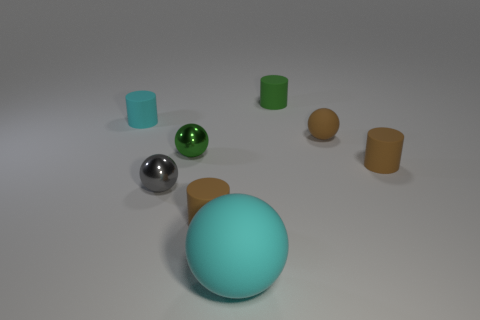Subtract all brown cylinders. How many were subtracted if there are1brown cylinders left? 1 Add 1 large cyan matte objects. How many objects exist? 9 Subtract all red balls. Subtract all brown cylinders. How many balls are left? 4 Add 5 small brown objects. How many small brown objects are left? 8 Add 1 small cylinders. How many small cylinders exist? 5 Subtract 0 cyan cubes. How many objects are left? 8 Subtract all small purple blocks. Subtract all green matte things. How many objects are left? 7 